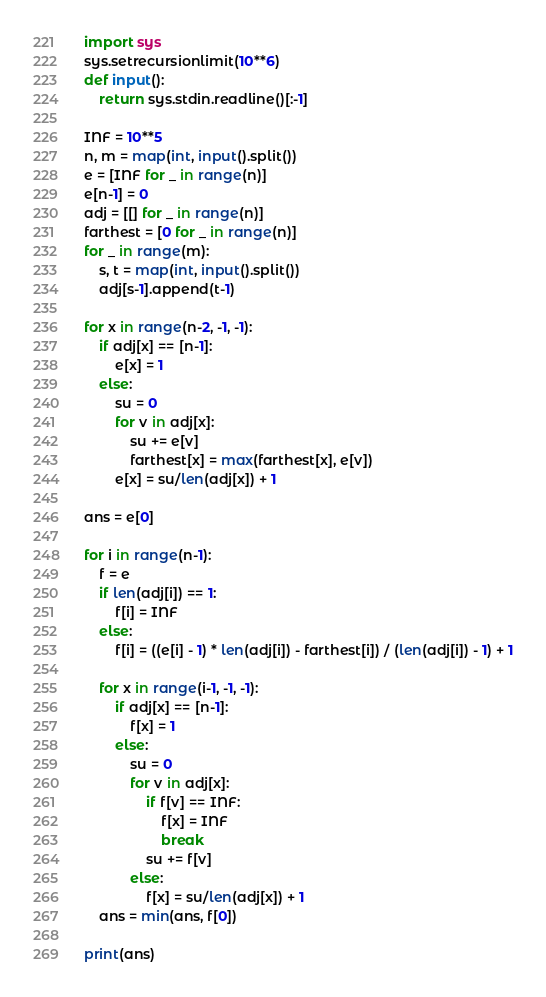Convert code to text. <code><loc_0><loc_0><loc_500><loc_500><_Python_>import sys
sys.setrecursionlimit(10**6)
def input():
	return sys.stdin.readline()[:-1]

INF = 10**5
n, m = map(int, input().split())
e = [INF for _ in range(n)]
e[n-1] = 0
adj = [[] for _ in range(n)]
farthest = [0 for _ in range(n)]
for _ in range(m):
	s, t = map(int, input().split())
	adj[s-1].append(t-1)

for x in range(n-2, -1, -1):
	if adj[x] == [n-1]:
		e[x] = 1		
	else:		
		su = 0
		for v in adj[x]:
			su += e[v]
			farthest[x] = max(farthest[x], e[v])
		e[x] = su/len(adj[x]) + 1

ans = e[0]

for i in range(n-1):
	f = e
	if len(adj[i]) == 1:
		f[i] = INF
	else:
		f[i] = ((e[i] - 1) * len(adj[i]) - farthest[i]) / (len(adj[i]) - 1) + 1

	for x in range(i-1, -1, -1):
		if adj[x] == [n-1]:
			f[x] = 1		
		else:		
			su = 0
			for v in adj[x]:
				if f[v] == INF:
					f[x] = INF
					break
				su += f[v]
			else:
				f[x] = su/len(adj[x]) + 1
	ans = min(ans, f[0])

print(ans)</code> 